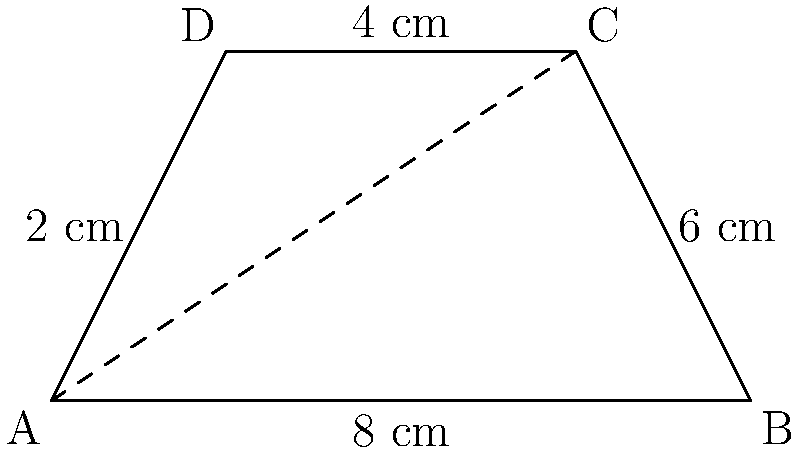A innovative tech startup wants to create a unique logo for their brand. They've decided on a trapezoid shape, as shown in the diagram. The parallel sides of the trapezoid measure 8 cm and 4 cm, while the height is 4 cm. As their business mentor, you're asked to calculate the area of this logo to help determine printing costs. What is the area of the trapezoid-shaped logo in square centimeters? Let's approach this step-by-step:

1) The formula for the area of a trapezoid is:
   $$A = \frac{1}{2}(b_1 + b_2)h$$
   where $A$ is the area, $b_1$ and $b_2$ are the lengths of the parallel sides, and $h$ is the height.

2) From the diagram, we can identify:
   $b_1 = 8$ cm (bottom base)
   $b_2 = 4$ cm (top base)
   $h = 4$ cm (height)

3) Let's substitute these values into our formula:
   $$A = \frac{1}{2}(8 + 4) \cdot 4$$

4) Simplify inside the parentheses:
   $$A = \frac{1}{2}(12) \cdot 4$$

5) Multiply:
   $$A = 6 \cdot 4 = 24$$

Therefore, the area of the trapezoid-shaped logo is 24 square centimeters.
Answer: 24 cm² 